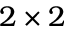<formula> <loc_0><loc_0><loc_500><loc_500>2 \times 2</formula> 